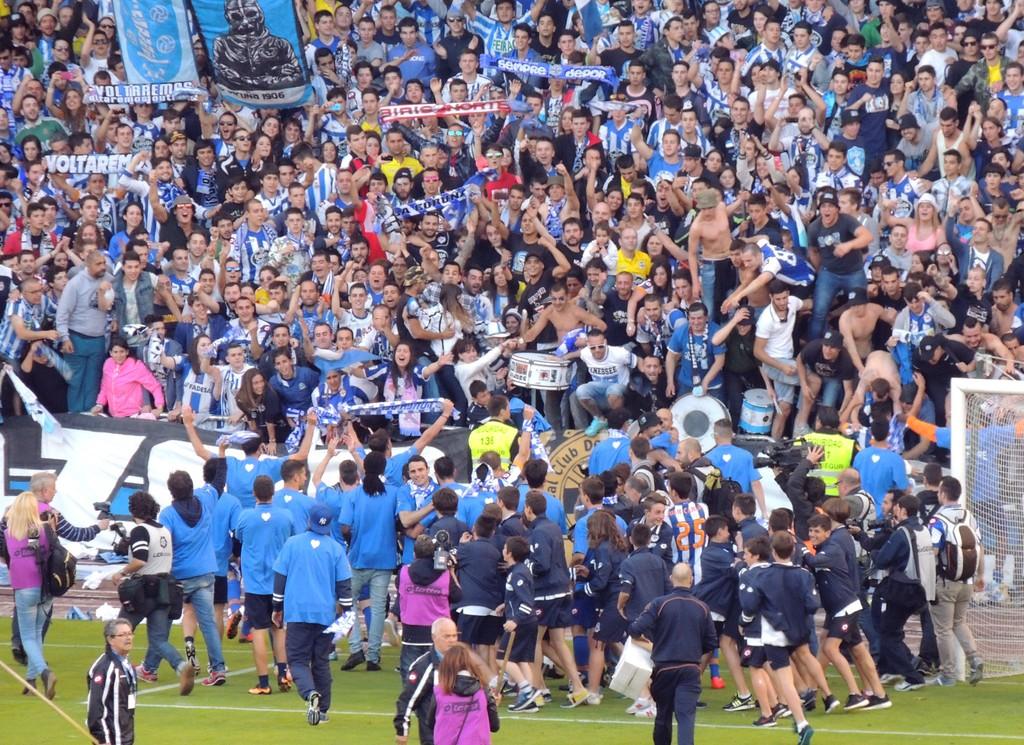What number is visible on the far right?
Give a very brief answer. Unanswerable. 